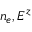<formula> <loc_0><loc_0><loc_500><loc_500>n _ { e } , E ^ { z }</formula> 